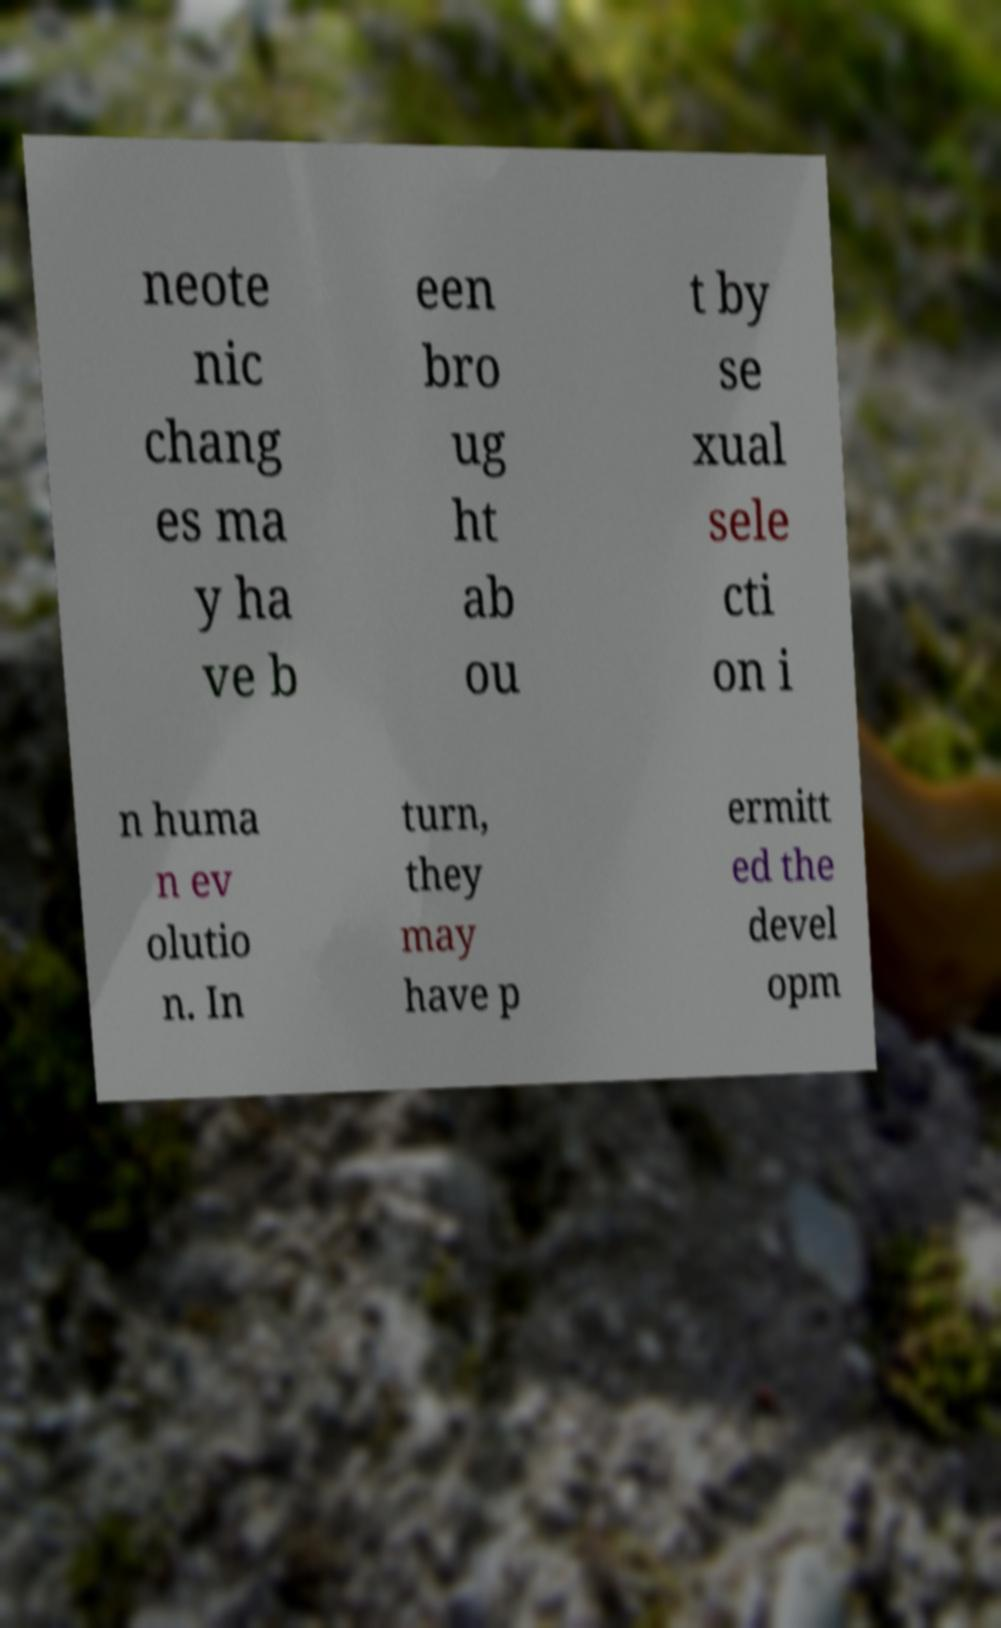Please read and relay the text visible in this image. What does it say? neote nic chang es ma y ha ve b een bro ug ht ab ou t by se xual sele cti on i n huma n ev olutio n. In turn, they may have p ermitt ed the devel opm 